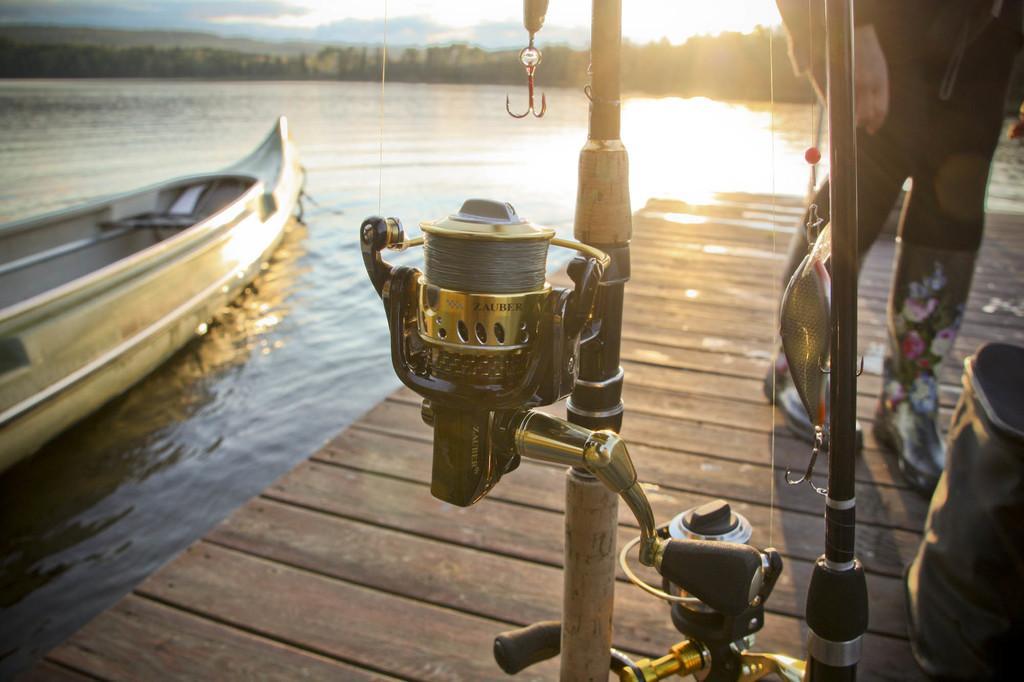Describe this image in one or two sentences. On the left side there is a boat in the water, on the right side a person is walking on this wooden floor. 